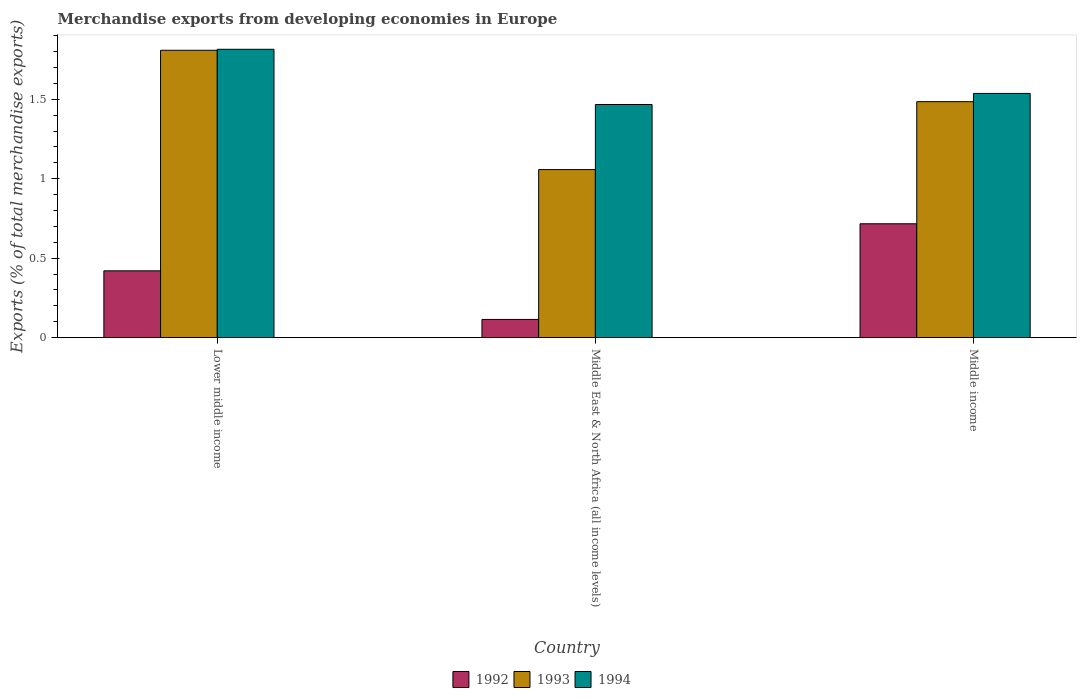How many different coloured bars are there?
Give a very brief answer. 3. How many groups of bars are there?
Provide a succinct answer. 3. Are the number of bars per tick equal to the number of legend labels?
Make the answer very short. Yes. Are the number of bars on each tick of the X-axis equal?
Give a very brief answer. Yes. How many bars are there on the 1st tick from the left?
Ensure brevity in your answer.  3. What is the label of the 2nd group of bars from the left?
Ensure brevity in your answer.  Middle East & North Africa (all income levels). In how many cases, is the number of bars for a given country not equal to the number of legend labels?
Your response must be concise. 0. What is the percentage of total merchandise exports in 1992 in Lower middle income?
Offer a terse response. 0.42. Across all countries, what is the maximum percentage of total merchandise exports in 1994?
Ensure brevity in your answer.  1.81. Across all countries, what is the minimum percentage of total merchandise exports in 1992?
Offer a very short reply. 0.11. In which country was the percentage of total merchandise exports in 1994 minimum?
Offer a terse response. Middle East & North Africa (all income levels). What is the total percentage of total merchandise exports in 1992 in the graph?
Your response must be concise. 1.25. What is the difference between the percentage of total merchandise exports in 1992 in Middle East & North Africa (all income levels) and that in Middle income?
Your answer should be compact. -0.6. What is the difference between the percentage of total merchandise exports in 1993 in Middle East & North Africa (all income levels) and the percentage of total merchandise exports in 1992 in Middle income?
Keep it short and to the point. 0.34. What is the average percentage of total merchandise exports in 1993 per country?
Keep it short and to the point. 1.45. What is the difference between the percentage of total merchandise exports of/in 1992 and percentage of total merchandise exports of/in 1994 in Middle East & North Africa (all income levels)?
Ensure brevity in your answer.  -1.35. In how many countries, is the percentage of total merchandise exports in 1993 greater than 1.7 %?
Offer a very short reply. 1. What is the ratio of the percentage of total merchandise exports in 1992 in Middle East & North Africa (all income levels) to that in Middle income?
Your answer should be compact. 0.16. Is the difference between the percentage of total merchandise exports in 1992 in Lower middle income and Middle income greater than the difference between the percentage of total merchandise exports in 1994 in Lower middle income and Middle income?
Your response must be concise. No. What is the difference between the highest and the second highest percentage of total merchandise exports in 1994?
Offer a terse response. 0.35. What is the difference between the highest and the lowest percentage of total merchandise exports in 1994?
Provide a short and direct response. 0.35. Is the sum of the percentage of total merchandise exports in 1993 in Lower middle income and Middle East & North Africa (all income levels) greater than the maximum percentage of total merchandise exports in 1994 across all countries?
Your answer should be very brief. Yes. What does the 2nd bar from the left in Middle East & North Africa (all income levels) represents?
Make the answer very short. 1993. Is it the case that in every country, the sum of the percentage of total merchandise exports in 1994 and percentage of total merchandise exports in 1993 is greater than the percentage of total merchandise exports in 1992?
Offer a very short reply. Yes. How many bars are there?
Make the answer very short. 9. Are all the bars in the graph horizontal?
Your response must be concise. No. How many countries are there in the graph?
Offer a very short reply. 3. Does the graph contain any zero values?
Provide a short and direct response. No. Does the graph contain grids?
Your answer should be very brief. No. Where does the legend appear in the graph?
Make the answer very short. Bottom center. How are the legend labels stacked?
Provide a succinct answer. Horizontal. What is the title of the graph?
Your answer should be very brief. Merchandise exports from developing economies in Europe. What is the label or title of the X-axis?
Offer a terse response. Country. What is the label or title of the Y-axis?
Your answer should be compact. Exports (% of total merchandise exports). What is the Exports (% of total merchandise exports) in 1992 in Lower middle income?
Ensure brevity in your answer.  0.42. What is the Exports (% of total merchandise exports) of 1993 in Lower middle income?
Give a very brief answer. 1.81. What is the Exports (% of total merchandise exports) in 1994 in Lower middle income?
Give a very brief answer. 1.81. What is the Exports (% of total merchandise exports) in 1992 in Middle East & North Africa (all income levels)?
Keep it short and to the point. 0.11. What is the Exports (% of total merchandise exports) of 1993 in Middle East & North Africa (all income levels)?
Make the answer very short. 1.06. What is the Exports (% of total merchandise exports) in 1994 in Middle East & North Africa (all income levels)?
Your response must be concise. 1.47. What is the Exports (% of total merchandise exports) of 1992 in Middle income?
Offer a terse response. 0.72. What is the Exports (% of total merchandise exports) of 1993 in Middle income?
Provide a short and direct response. 1.48. What is the Exports (% of total merchandise exports) in 1994 in Middle income?
Offer a very short reply. 1.54. Across all countries, what is the maximum Exports (% of total merchandise exports) of 1992?
Provide a succinct answer. 0.72. Across all countries, what is the maximum Exports (% of total merchandise exports) in 1993?
Your answer should be very brief. 1.81. Across all countries, what is the maximum Exports (% of total merchandise exports) of 1994?
Give a very brief answer. 1.81. Across all countries, what is the minimum Exports (% of total merchandise exports) of 1992?
Make the answer very short. 0.11. Across all countries, what is the minimum Exports (% of total merchandise exports) of 1993?
Make the answer very short. 1.06. Across all countries, what is the minimum Exports (% of total merchandise exports) in 1994?
Your response must be concise. 1.47. What is the total Exports (% of total merchandise exports) of 1992 in the graph?
Offer a terse response. 1.25. What is the total Exports (% of total merchandise exports) of 1993 in the graph?
Your answer should be very brief. 4.35. What is the total Exports (% of total merchandise exports) in 1994 in the graph?
Keep it short and to the point. 4.82. What is the difference between the Exports (% of total merchandise exports) in 1992 in Lower middle income and that in Middle East & North Africa (all income levels)?
Make the answer very short. 0.31. What is the difference between the Exports (% of total merchandise exports) in 1993 in Lower middle income and that in Middle East & North Africa (all income levels)?
Offer a very short reply. 0.75. What is the difference between the Exports (% of total merchandise exports) of 1994 in Lower middle income and that in Middle East & North Africa (all income levels)?
Make the answer very short. 0.35. What is the difference between the Exports (% of total merchandise exports) of 1992 in Lower middle income and that in Middle income?
Ensure brevity in your answer.  -0.3. What is the difference between the Exports (% of total merchandise exports) in 1993 in Lower middle income and that in Middle income?
Keep it short and to the point. 0.32. What is the difference between the Exports (% of total merchandise exports) in 1994 in Lower middle income and that in Middle income?
Keep it short and to the point. 0.28. What is the difference between the Exports (% of total merchandise exports) in 1992 in Middle East & North Africa (all income levels) and that in Middle income?
Ensure brevity in your answer.  -0.6. What is the difference between the Exports (% of total merchandise exports) of 1993 in Middle East & North Africa (all income levels) and that in Middle income?
Provide a succinct answer. -0.43. What is the difference between the Exports (% of total merchandise exports) in 1994 in Middle East & North Africa (all income levels) and that in Middle income?
Provide a short and direct response. -0.07. What is the difference between the Exports (% of total merchandise exports) in 1992 in Lower middle income and the Exports (% of total merchandise exports) in 1993 in Middle East & North Africa (all income levels)?
Ensure brevity in your answer.  -0.64. What is the difference between the Exports (% of total merchandise exports) in 1992 in Lower middle income and the Exports (% of total merchandise exports) in 1994 in Middle East & North Africa (all income levels)?
Your answer should be very brief. -1.05. What is the difference between the Exports (% of total merchandise exports) in 1993 in Lower middle income and the Exports (% of total merchandise exports) in 1994 in Middle East & North Africa (all income levels)?
Give a very brief answer. 0.34. What is the difference between the Exports (% of total merchandise exports) in 1992 in Lower middle income and the Exports (% of total merchandise exports) in 1993 in Middle income?
Offer a very short reply. -1.06. What is the difference between the Exports (% of total merchandise exports) in 1992 in Lower middle income and the Exports (% of total merchandise exports) in 1994 in Middle income?
Keep it short and to the point. -1.12. What is the difference between the Exports (% of total merchandise exports) in 1993 in Lower middle income and the Exports (% of total merchandise exports) in 1994 in Middle income?
Ensure brevity in your answer.  0.27. What is the difference between the Exports (% of total merchandise exports) of 1992 in Middle East & North Africa (all income levels) and the Exports (% of total merchandise exports) of 1993 in Middle income?
Provide a short and direct response. -1.37. What is the difference between the Exports (% of total merchandise exports) in 1992 in Middle East & North Africa (all income levels) and the Exports (% of total merchandise exports) in 1994 in Middle income?
Provide a short and direct response. -1.42. What is the difference between the Exports (% of total merchandise exports) in 1993 in Middle East & North Africa (all income levels) and the Exports (% of total merchandise exports) in 1994 in Middle income?
Your answer should be compact. -0.48. What is the average Exports (% of total merchandise exports) of 1992 per country?
Ensure brevity in your answer.  0.42. What is the average Exports (% of total merchandise exports) of 1993 per country?
Ensure brevity in your answer.  1.45. What is the average Exports (% of total merchandise exports) of 1994 per country?
Make the answer very short. 1.61. What is the difference between the Exports (% of total merchandise exports) of 1992 and Exports (% of total merchandise exports) of 1993 in Lower middle income?
Keep it short and to the point. -1.39. What is the difference between the Exports (% of total merchandise exports) in 1992 and Exports (% of total merchandise exports) in 1994 in Lower middle income?
Ensure brevity in your answer.  -1.39. What is the difference between the Exports (% of total merchandise exports) of 1993 and Exports (% of total merchandise exports) of 1994 in Lower middle income?
Provide a succinct answer. -0.01. What is the difference between the Exports (% of total merchandise exports) of 1992 and Exports (% of total merchandise exports) of 1993 in Middle East & North Africa (all income levels)?
Give a very brief answer. -0.94. What is the difference between the Exports (% of total merchandise exports) of 1992 and Exports (% of total merchandise exports) of 1994 in Middle East & North Africa (all income levels)?
Keep it short and to the point. -1.35. What is the difference between the Exports (% of total merchandise exports) of 1993 and Exports (% of total merchandise exports) of 1994 in Middle East & North Africa (all income levels)?
Your response must be concise. -0.41. What is the difference between the Exports (% of total merchandise exports) in 1992 and Exports (% of total merchandise exports) in 1993 in Middle income?
Keep it short and to the point. -0.77. What is the difference between the Exports (% of total merchandise exports) of 1992 and Exports (% of total merchandise exports) of 1994 in Middle income?
Your answer should be compact. -0.82. What is the difference between the Exports (% of total merchandise exports) in 1993 and Exports (% of total merchandise exports) in 1994 in Middle income?
Offer a very short reply. -0.05. What is the ratio of the Exports (% of total merchandise exports) in 1992 in Lower middle income to that in Middle East & North Africa (all income levels)?
Provide a succinct answer. 3.67. What is the ratio of the Exports (% of total merchandise exports) in 1993 in Lower middle income to that in Middle East & North Africa (all income levels)?
Your answer should be very brief. 1.71. What is the ratio of the Exports (% of total merchandise exports) of 1994 in Lower middle income to that in Middle East & North Africa (all income levels)?
Your response must be concise. 1.24. What is the ratio of the Exports (% of total merchandise exports) of 1992 in Lower middle income to that in Middle income?
Your answer should be very brief. 0.59. What is the ratio of the Exports (% of total merchandise exports) in 1993 in Lower middle income to that in Middle income?
Keep it short and to the point. 1.22. What is the ratio of the Exports (% of total merchandise exports) in 1994 in Lower middle income to that in Middle income?
Provide a short and direct response. 1.18. What is the ratio of the Exports (% of total merchandise exports) in 1992 in Middle East & North Africa (all income levels) to that in Middle income?
Provide a short and direct response. 0.16. What is the ratio of the Exports (% of total merchandise exports) of 1993 in Middle East & North Africa (all income levels) to that in Middle income?
Keep it short and to the point. 0.71. What is the ratio of the Exports (% of total merchandise exports) in 1994 in Middle East & North Africa (all income levels) to that in Middle income?
Your response must be concise. 0.95. What is the difference between the highest and the second highest Exports (% of total merchandise exports) of 1992?
Ensure brevity in your answer.  0.3. What is the difference between the highest and the second highest Exports (% of total merchandise exports) of 1993?
Your answer should be compact. 0.32. What is the difference between the highest and the second highest Exports (% of total merchandise exports) in 1994?
Provide a succinct answer. 0.28. What is the difference between the highest and the lowest Exports (% of total merchandise exports) in 1992?
Provide a short and direct response. 0.6. What is the difference between the highest and the lowest Exports (% of total merchandise exports) of 1993?
Your answer should be very brief. 0.75. What is the difference between the highest and the lowest Exports (% of total merchandise exports) of 1994?
Ensure brevity in your answer.  0.35. 